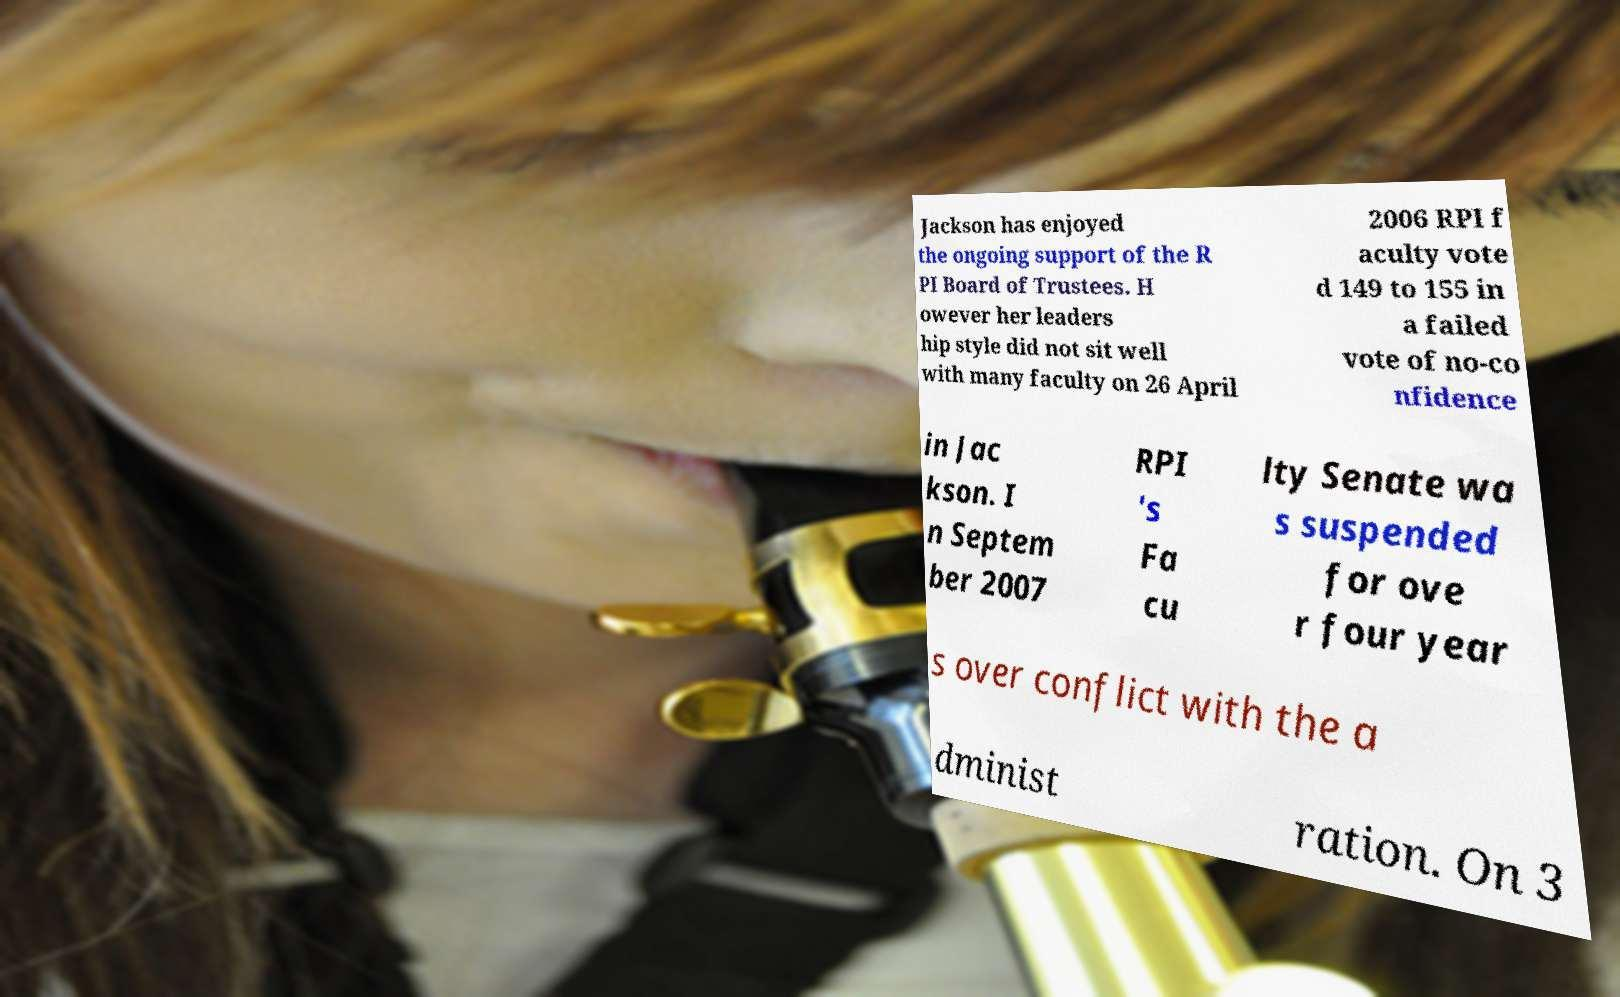Please read and relay the text visible in this image. What does it say? Jackson has enjoyed the ongoing support of the R PI Board of Trustees. H owever her leaders hip style did not sit well with many faculty on 26 April 2006 RPI f aculty vote d 149 to 155 in a failed vote of no-co nfidence in Jac kson. I n Septem ber 2007 RPI 's Fa cu lty Senate wa s suspended for ove r four year s over conflict with the a dminist ration. On 3 